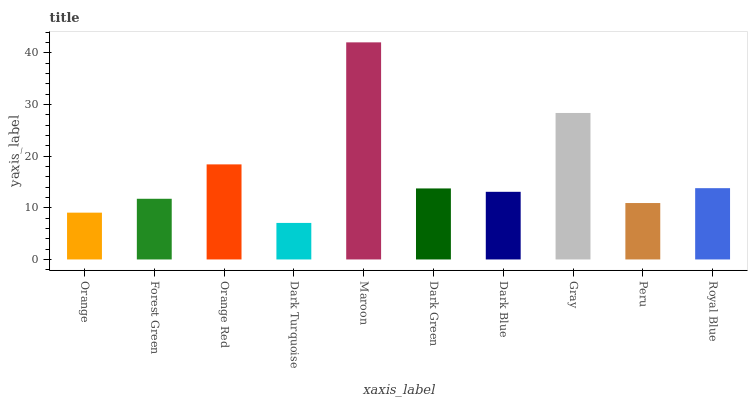Is Forest Green the minimum?
Answer yes or no. No. Is Forest Green the maximum?
Answer yes or no. No. Is Forest Green greater than Orange?
Answer yes or no. Yes. Is Orange less than Forest Green?
Answer yes or no. Yes. Is Orange greater than Forest Green?
Answer yes or no. No. Is Forest Green less than Orange?
Answer yes or no. No. Is Dark Green the high median?
Answer yes or no. Yes. Is Dark Blue the low median?
Answer yes or no. Yes. Is Forest Green the high median?
Answer yes or no. No. Is Dark Green the low median?
Answer yes or no. No. 